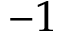Convert formula to latex. <formula><loc_0><loc_0><loc_500><loc_500>- 1</formula> 